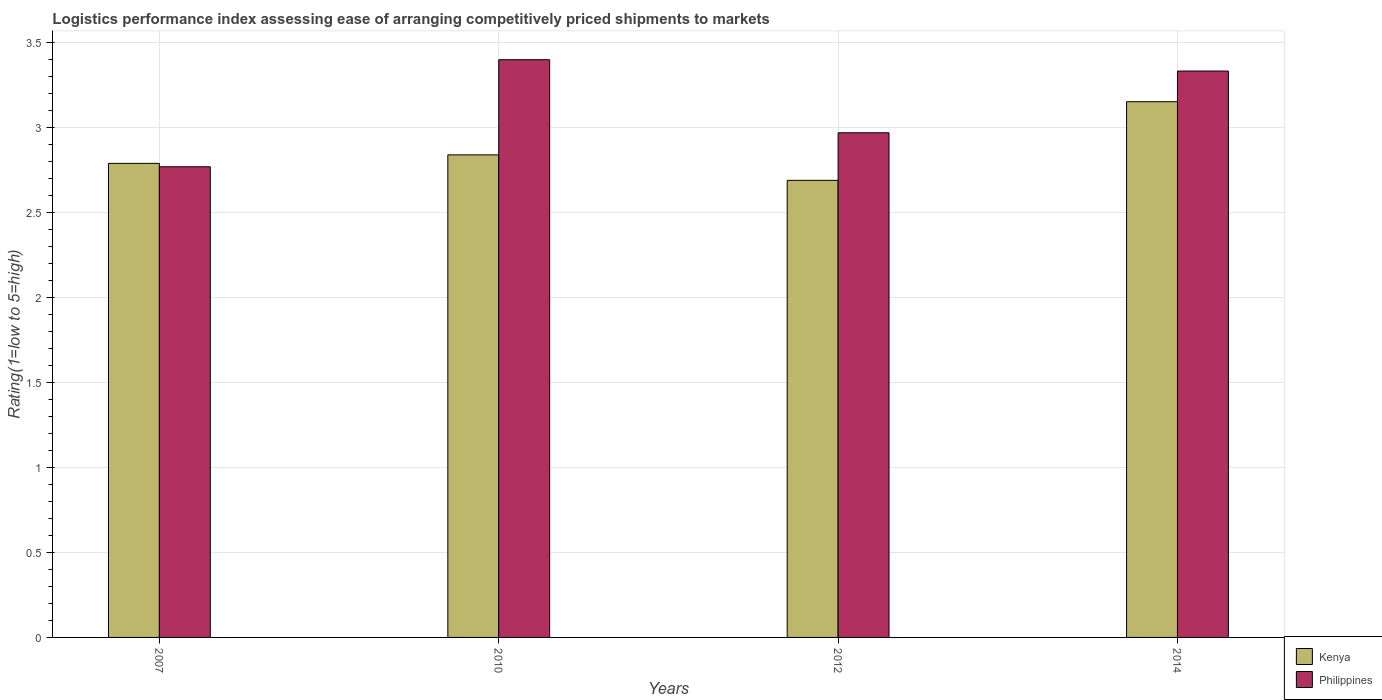How many different coloured bars are there?
Make the answer very short. 2. How many groups of bars are there?
Give a very brief answer. 4. Are the number of bars per tick equal to the number of legend labels?
Provide a succinct answer. Yes. Are the number of bars on each tick of the X-axis equal?
Provide a short and direct response. Yes. How many bars are there on the 1st tick from the left?
Your answer should be compact. 2. How many bars are there on the 2nd tick from the right?
Offer a very short reply. 2. In how many cases, is the number of bars for a given year not equal to the number of legend labels?
Offer a terse response. 0. What is the Logistic performance index in Philippines in 2012?
Make the answer very short. 2.97. Across all years, what is the maximum Logistic performance index in Philippines?
Keep it short and to the point. 3.4. Across all years, what is the minimum Logistic performance index in Philippines?
Ensure brevity in your answer.  2.77. What is the total Logistic performance index in Philippines in the graph?
Your answer should be compact. 12.47. What is the difference between the Logistic performance index in Kenya in 2010 and that in 2014?
Ensure brevity in your answer.  -0.31. What is the difference between the Logistic performance index in Philippines in 2010 and the Logistic performance index in Kenya in 2014?
Provide a succinct answer. 0.25. What is the average Logistic performance index in Philippines per year?
Give a very brief answer. 3.12. In the year 2012, what is the difference between the Logistic performance index in Philippines and Logistic performance index in Kenya?
Ensure brevity in your answer.  0.28. What is the ratio of the Logistic performance index in Kenya in 2010 to that in 2012?
Offer a very short reply. 1.06. Is the Logistic performance index in Philippines in 2010 less than that in 2012?
Offer a very short reply. No. Is the difference between the Logistic performance index in Philippines in 2007 and 2014 greater than the difference between the Logistic performance index in Kenya in 2007 and 2014?
Provide a succinct answer. No. What is the difference between the highest and the second highest Logistic performance index in Philippines?
Your answer should be very brief. 0.07. What is the difference between the highest and the lowest Logistic performance index in Kenya?
Make the answer very short. 0.46. In how many years, is the Logistic performance index in Kenya greater than the average Logistic performance index in Kenya taken over all years?
Your answer should be compact. 1. Is the sum of the Logistic performance index in Kenya in 2010 and 2012 greater than the maximum Logistic performance index in Philippines across all years?
Provide a succinct answer. Yes. What does the 2nd bar from the left in 2014 represents?
Your answer should be compact. Philippines. How many bars are there?
Make the answer very short. 8. Are all the bars in the graph horizontal?
Provide a succinct answer. No. What is the difference between two consecutive major ticks on the Y-axis?
Your answer should be compact. 0.5. Does the graph contain any zero values?
Make the answer very short. No. How many legend labels are there?
Give a very brief answer. 2. What is the title of the graph?
Your response must be concise. Logistics performance index assessing ease of arranging competitively priced shipments to markets. Does "French Polynesia" appear as one of the legend labels in the graph?
Offer a terse response. No. What is the label or title of the X-axis?
Ensure brevity in your answer.  Years. What is the label or title of the Y-axis?
Your answer should be compact. Rating(1=low to 5=high). What is the Rating(1=low to 5=high) in Kenya in 2007?
Give a very brief answer. 2.79. What is the Rating(1=low to 5=high) of Philippines in 2007?
Offer a very short reply. 2.77. What is the Rating(1=low to 5=high) in Kenya in 2010?
Offer a very short reply. 2.84. What is the Rating(1=low to 5=high) of Philippines in 2010?
Your answer should be compact. 3.4. What is the Rating(1=low to 5=high) of Kenya in 2012?
Give a very brief answer. 2.69. What is the Rating(1=low to 5=high) in Philippines in 2012?
Your response must be concise. 2.97. What is the Rating(1=low to 5=high) in Kenya in 2014?
Provide a short and direct response. 3.15. What is the Rating(1=low to 5=high) of Philippines in 2014?
Your answer should be compact. 3.33. Across all years, what is the maximum Rating(1=low to 5=high) in Kenya?
Offer a very short reply. 3.15. Across all years, what is the maximum Rating(1=low to 5=high) of Philippines?
Your response must be concise. 3.4. Across all years, what is the minimum Rating(1=low to 5=high) of Kenya?
Provide a succinct answer. 2.69. Across all years, what is the minimum Rating(1=low to 5=high) in Philippines?
Provide a short and direct response. 2.77. What is the total Rating(1=low to 5=high) of Kenya in the graph?
Make the answer very short. 11.47. What is the total Rating(1=low to 5=high) of Philippines in the graph?
Keep it short and to the point. 12.47. What is the difference between the Rating(1=low to 5=high) in Philippines in 2007 and that in 2010?
Provide a short and direct response. -0.63. What is the difference between the Rating(1=low to 5=high) of Kenya in 2007 and that in 2014?
Offer a very short reply. -0.36. What is the difference between the Rating(1=low to 5=high) of Philippines in 2007 and that in 2014?
Offer a terse response. -0.56. What is the difference between the Rating(1=low to 5=high) in Kenya in 2010 and that in 2012?
Make the answer very short. 0.15. What is the difference between the Rating(1=low to 5=high) of Philippines in 2010 and that in 2012?
Give a very brief answer. 0.43. What is the difference between the Rating(1=low to 5=high) of Kenya in 2010 and that in 2014?
Your answer should be very brief. -0.31. What is the difference between the Rating(1=low to 5=high) in Philippines in 2010 and that in 2014?
Give a very brief answer. 0.07. What is the difference between the Rating(1=low to 5=high) of Kenya in 2012 and that in 2014?
Offer a very short reply. -0.46. What is the difference between the Rating(1=low to 5=high) in Philippines in 2012 and that in 2014?
Your response must be concise. -0.36. What is the difference between the Rating(1=low to 5=high) in Kenya in 2007 and the Rating(1=low to 5=high) in Philippines in 2010?
Offer a terse response. -0.61. What is the difference between the Rating(1=low to 5=high) of Kenya in 2007 and the Rating(1=low to 5=high) of Philippines in 2012?
Keep it short and to the point. -0.18. What is the difference between the Rating(1=low to 5=high) of Kenya in 2007 and the Rating(1=low to 5=high) of Philippines in 2014?
Provide a short and direct response. -0.54. What is the difference between the Rating(1=low to 5=high) in Kenya in 2010 and the Rating(1=low to 5=high) in Philippines in 2012?
Make the answer very short. -0.13. What is the difference between the Rating(1=low to 5=high) in Kenya in 2010 and the Rating(1=low to 5=high) in Philippines in 2014?
Your answer should be compact. -0.49. What is the difference between the Rating(1=low to 5=high) of Kenya in 2012 and the Rating(1=low to 5=high) of Philippines in 2014?
Make the answer very short. -0.64. What is the average Rating(1=low to 5=high) of Kenya per year?
Your answer should be very brief. 2.87. What is the average Rating(1=low to 5=high) of Philippines per year?
Your answer should be compact. 3.12. In the year 2010, what is the difference between the Rating(1=low to 5=high) in Kenya and Rating(1=low to 5=high) in Philippines?
Ensure brevity in your answer.  -0.56. In the year 2012, what is the difference between the Rating(1=low to 5=high) in Kenya and Rating(1=low to 5=high) in Philippines?
Ensure brevity in your answer.  -0.28. In the year 2014, what is the difference between the Rating(1=low to 5=high) of Kenya and Rating(1=low to 5=high) of Philippines?
Make the answer very short. -0.18. What is the ratio of the Rating(1=low to 5=high) of Kenya in 2007 to that in 2010?
Provide a short and direct response. 0.98. What is the ratio of the Rating(1=low to 5=high) of Philippines in 2007 to that in 2010?
Your response must be concise. 0.81. What is the ratio of the Rating(1=low to 5=high) of Kenya in 2007 to that in 2012?
Make the answer very short. 1.04. What is the ratio of the Rating(1=low to 5=high) of Philippines in 2007 to that in 2012?
Keep it short and to the point. 0.93. What is the ratio of the Rating(1=low to 5=high) of Kenya in 2007 to that in 2014?
Your response must be concise. 0.88. What is the ratio of the Rating(1=low to 5=high) in Philippines in 2007 to that in 2014?
Your answer should be compact. 0.83. What is the ratio of the Rating(1=low to 5=high) of Kenya in 2010 to that in 2012?
Keep it short and to the point. 1.06. What is the ratio of the Rating(1=low to 5=high) of Philippines in 2010 to that in 2012?
Your response must be concise. 1.14. What is the ratio of the Rating(1=low to 5=high) of Kenya in 2010 to that in 2014?
Provide a short and direct response. 0.9. What is the ratio of the Rating(1=low to 5=high) of Philippines in 2010 to that in 2014?
Your answer should be compact. 1.02. What is the ratio of the Rating(1=low to 5=high) in Kenya in 2012 to that in 2014?
Ensure brevity in your answer.  0.85. What is the ratio of the Rating(1=low to 5=high) of Philippines in 2012 to that in 2014?
Your answer should be very brief. 0.89. What is the difference between the highest and the second highest Rating(1=low to 5=high) of Kenya?
Ensure brevity in your answer.  0.31. What is the difference between the highest and the second highest Rating(1=low to 5=high) of Philippines?
Provide a short and direct response. 0.07. What is the difference between the highest and the lowest Rating(1=low to 5=high) in Kenya?
Ensure brevity in your answer.  0.46. What is the difference between the highest and the lowest Rating(1=low to 5=high) of Philippines?
Ensure brevity in your answer.  0.63. 